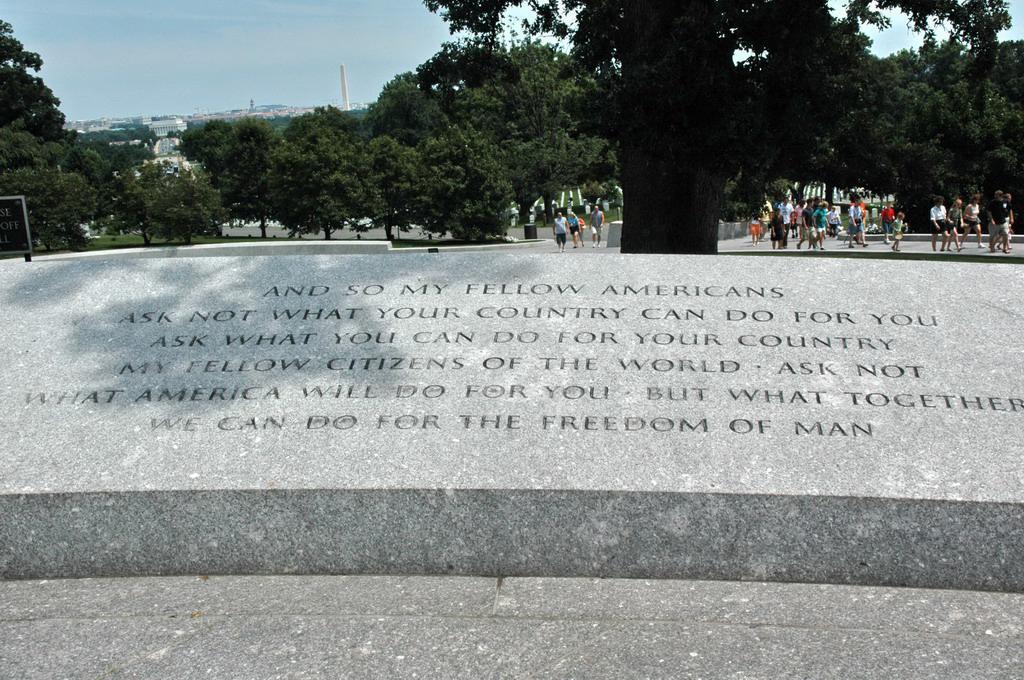In one or two sentences, can you explain what this image depicts? In this image there is some text on the wall, behind that there are a few people walking on the path, there are trees, buildings and in the background there is the sky. 